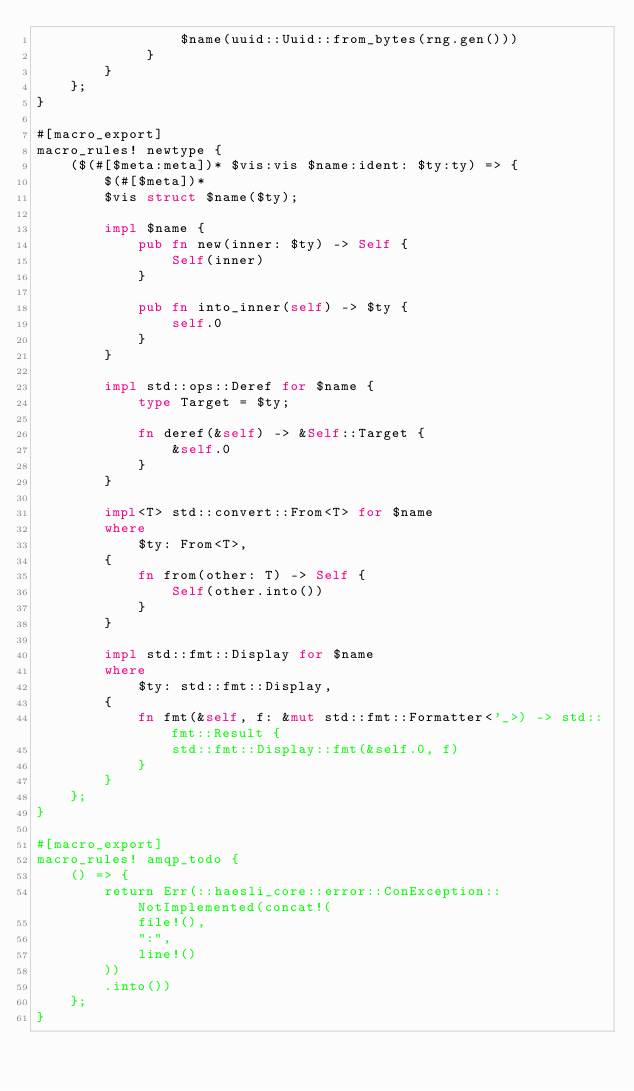<code> <loc_0><loc_0><loc_500><loc_500><_Rust_>                 $name(uuid::Uuid::from_bytes(rng.gen()))
             }
        }
    };
}

#[macro_export]
macro_rules! newtype {
    ($(#[$meta:meta])* $vis:vis $name:ident: $ty:ty) => {
        $(#[$meta])*
        $vis struct $name($ty);

        impl $name {
            pub fn new(inner: $ty) -> Self {
                Self(inner)
            }

            pub fn into_inner(self) -> $ty {
                self.0
            }
        }

        impl std::ops::Deref for $name {
            type Target = $ty;

            fn deref(&self) -> &Self::Target {
                &self.0
            }
        }

        impl<T> std::convert::From<T> for $name
        where
            $ty: From<T>,
        {
            fn from(other: T) -> Self {
                Self(other.into())
            }
        }

        impl std::fmt::Display for $name
        where
            $ty: std::fmt::Display,
        {
            fn fmt(&self, f: &mut std::fmt::Formatter<'_>) -> std::fmt::Result {
                std::fmt::Display::fmt(&self.0, f)
            }
        }
    };
}

#[macro_export]
macro_rules! amqp_todo {
    () => {
        return Err(::haesli_core::error::ConException::NotImplemented(concat!(
            file!(),
            ":",
            line!()
        ))
        .into())
    };
}
</code> 